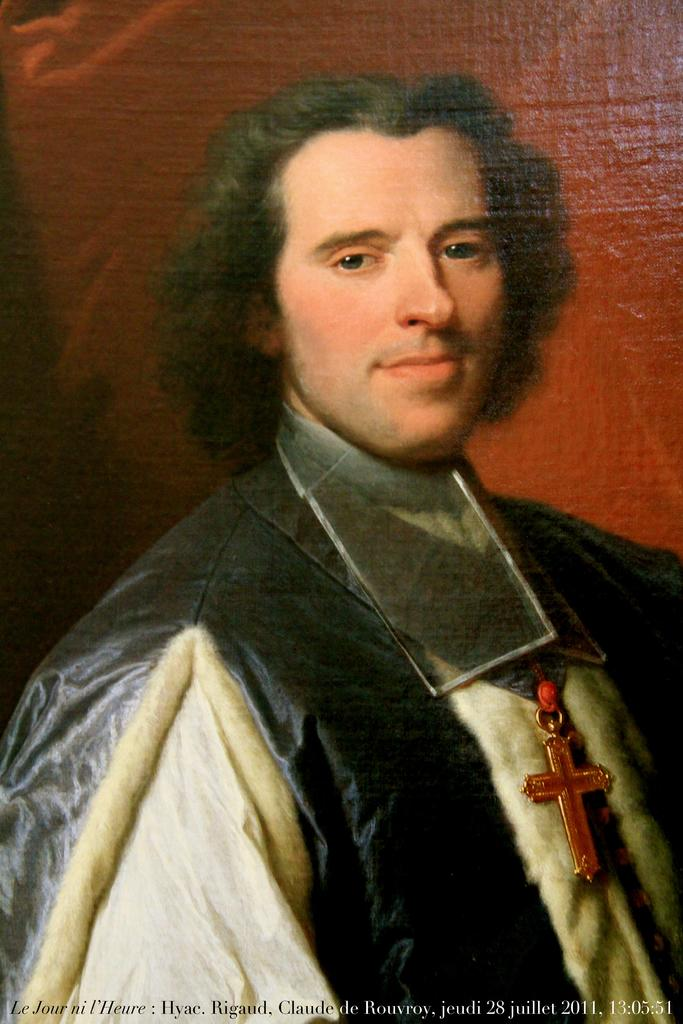What is depicted in the image? There is a painting of a man in the image. What is the man wearing in the painting? The man is wearing a black and white dress. What color is the background of the painting? The background of the painting is red. Can you describe any additional features of the image? There is a watermark in the image. What type of police vehicle can be seen in the image? There is no police vehicle present in the image; it features a painting of a man. Can you describe the man's breathing pattern in the image? The image is a painting, and as such, it does not depict the man's breathing pattern. 